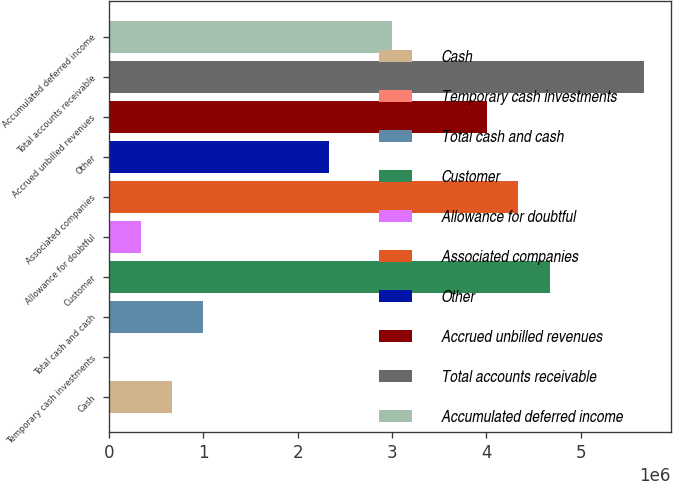Convert chart to OTSL. <chart><loc_0><loc_0><loc_500><loc_500><bar_chart><fcel>Cash<fcel>Temporary cash investments<fcel>Total cash and cash<fcel>Customer<fcel>Allowance for doubtful<fcel>Associated companies<fcel>Other<fcel>Accrued unbilled revenues<fcel>Total accounts receivable<fcel>Accumulated deferred income<nl><fcel>666910<fcel>9<fcel>1.00036e+06<fcel>4.66832e+06<fcel>333460<fcel>4.33487e+06<fcel>2.33416e+06<fcel>4.00142e+06<fcel>5.66867e+06<fcel>3.00106e+06<nl></chart> 